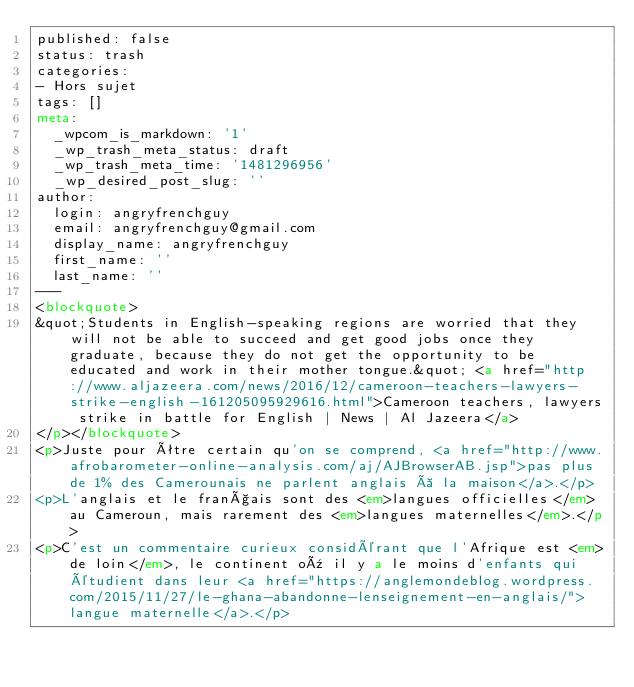Convert code to text. <code><loc_0><loc_0><loc_500><loc_500><_HTML_>published: false
status: trash
categories:
- Hors sujet
tags: []
meta:
  _wpcom_is_markdown: '1'
  _wp_trash_meta_status: draft
  _wp_trash_meta_time: '1481296956'
  _wp_desired_post_slug: ''
author:
  login: angryfrenchguy
  email: angryfrenchguy@gmail.com
  display_name: angryfrenchguy
  first_name: ''
  last_name: ''
---
<blockquote>
&quot;Students in English-speaking regions are worried that they will not be able to succeed and get good jobs once they graduate, because they do not get the opportunity to be educated and work in their mother tongue.&quot; <a href="http://www.aljazeera.com/news/2016/12/cameroon-teachers-lawyers-strike-english-161205095929616.html">Cameroon teachers, lawyers strike in battle for English | News | Al Jazeera</a>
</p></blockquote>
<p>Juste pour être certain qu'on se comprend, <a href="http://www.afrobarometer-online-analysis.com/aj/AJBrowserAB.jsp">pas plus de 1% des Camerounais ne parlent anglais à la maison</a>.</p>
<p>L'anglais et le français sont des <em>langues officielles</em> au Cameroun, mais rarement des <em>langues maternelles</em>.</p>
<p>C'est un commentaire curieux considérant que l'Afrique est <em>de loin</em>, le continent où il y a le moins d'enfants qui étudient dans leur <a href="https://anglemondeblog.wordpress.com/2015/11/27/le-ghana-abandonne-lenseignement-en-anglais/">langue maternelle</a>.</p>
</code> 